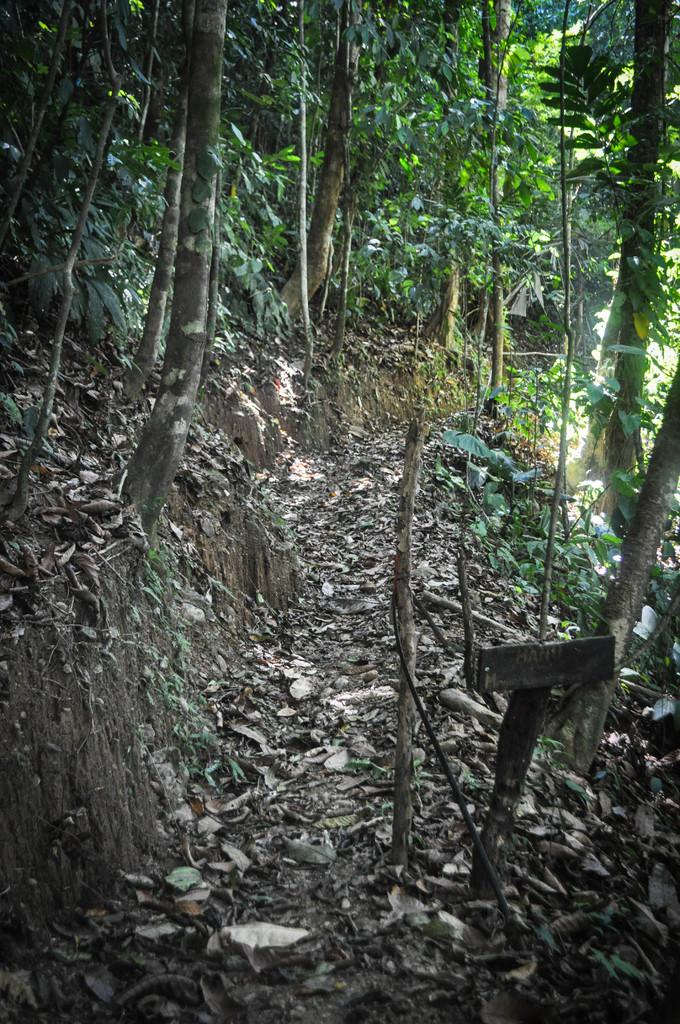What is on the ground in the image? There are dry leaves on the ground in the image. What type of vegetation can be seen in the image? There are trees in the image. What type of canvas is visible in the image? There is no canvas present in the image. What substance is being transported by the boats in the image? There are no boats present in the image. 